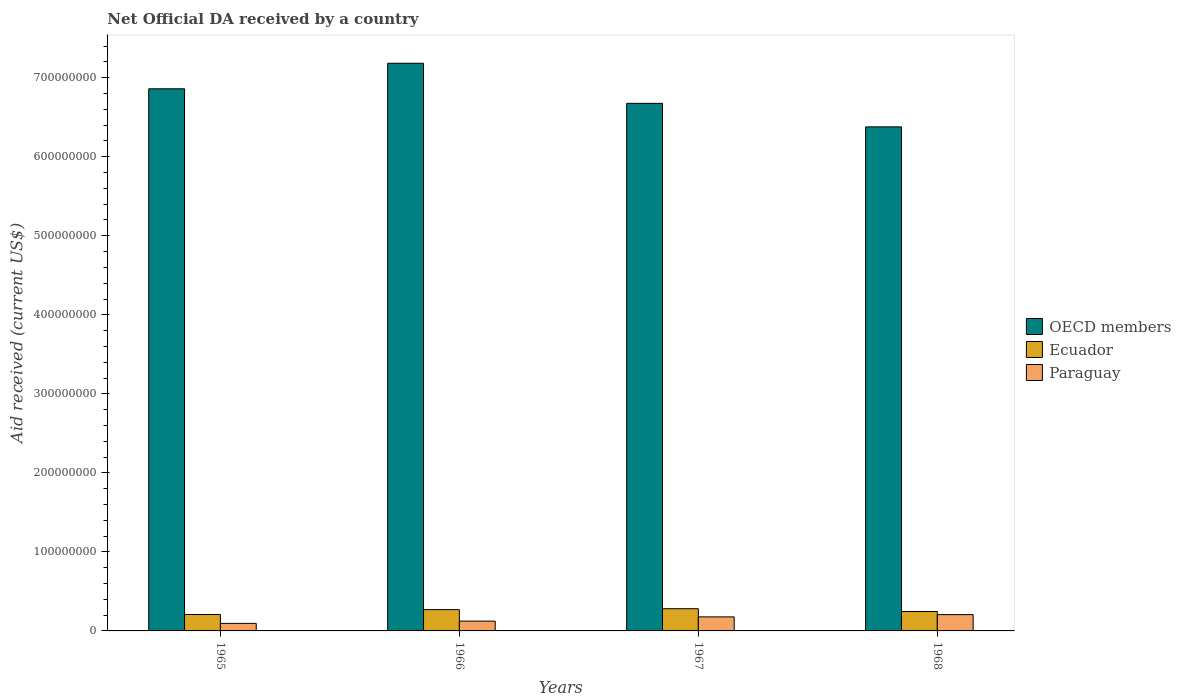How many different coloured bars are there?
Give a very brief answer. 3. Are the number of bars per tick equal to the number of legend labels?
Give a very brief answer. Yes. Are the number of bars on each tick of the X-axis equal?
Offer a terse response. Yes. What is the label of the 3rd group of bars from the left?
Your answer should be compact. 1967. What is the net official development assistance aid received in Ecuador in 1965?
Offer a very short reply. 2.08e+07. Across all years, what is the maximum net official development assistance aid received in OECD members?
Provide a short and direct response. 7.18e+08. Across all years, what is the minimum net official development assistance aid received in OECD members?
Offer a very short reply. 6.38e+08. In which year was the net official development assistance aid received in Ecuador maximum?
Provide a succinct answer. 1967. In which year was the net official development assistance aid received in Paraguay minimum?
Your answer should be compact. 1965. What is the total net official development assistance aid received in Ecuador in the graph?
Offer a terse response. 1.00e+08. What is the difference between the net official development assistance aid received in Paraguay in 1965 and that in 1966?
Your answer should be very brief. -2.85e+06. What is the difference between the net official development assistance aid received in OECD members in 1965 and the net official development assistance aid received in Paraguay in 1968?
Make the answer very short. 6.65e+08. What is the average net official development assistance aid received in OECD members per year?
Provide a short and direct response. 6.77e+08. In the year 1967, what is the difference between the net official development assistance aid received in OECD members and net official development assistance aid received in Paraguay?
Your answer should be very brief. 6.50e+08. In how many years, is the net official development assistance aid received in OECD members greater than 700000000 US$?
Provide a succinct answer. 1. What is the ratio of the net official development assistance aid received in Ecuador in 1967 to that in 1968?
Your response must be concise. 1.14. Is the net official development assistance aid received in Ecuador in 1965 less than that in 1967?
Your answer should be compact. Yes. Is the difference between the net official development assistance aid received in OECD members in 1967 and 1968 greater than the difference between the net official development assistance aid received in Paraguay in 1967 and 1968?
Offer a terse response. Yes. What is the difference between the highest and the second highest net official development assistance aid received in OECD members?
Give a very brief answer. 3.23e+07. What is the difference between the highest and the lowest net official development assistance aid received in Paraguay?
Your answer should be very brief. 1.11e+07. In how many years, is the net official development assistance aid received in Paraguay greater than the average net official development assistance aid received in Paraguay taken over all years?
Provide a short and direct response. 2. Is the sum of the net official development assistance aid received in Paraguay in 1965 and 1968 greater than the maximum net official development assistance aid received in Ecuador across all years?
Give a very brief answer. Yes. What does the 2nd bar from the left in 1968 represents?
Provide a short and direct response. Ecuador. What does the 2nd bar from the right in 1966 represents?
Offer a terse response. Ecuador. How many years are there in the graph?
Your answer should be compact. 4. Does the graph contain grids?
Ensure brevity in your answer.  No. How many legend labels are there?
Ensure brevity in your answer.  3. How are the legend labels stacked?
Make the answer very short. Vertical. What is the title of the graph?
Offer a very short reply. Net Official DA received by a country. Does "Jordan" appear as one of the legend labels in the graph?
Offer a very short reply. No. What is the label or title of the Y-axis?
Provide a succinct answer. Aid received (current US$). What is the Aid received (current US$) in OECD members in 1965?
Your answer should be very brief. 6.86e+08. What is the Aid received (current US$) in Ecuador in 1965?
Offer a very short reply. 2.08e+07. What is the Aid received (current US$) in Paraguay in 1965?
Provide a short and direct response. 9.55e+06. What is the Aid received (current US$) in OECD members in 1966?
Offer a very short reply. 7.18e+08. What is the Aid received (current US$) in Ecuador in 1966?
Offer a very short reply. 2.69e+07. What is the Aid received (current US$) in Paraguay in 1966?
Ensure brevity in your answer.  1.24e+07. What is the Aid received (current US$) in OECD members in 1967?
Your answer should be very brief. 6.68e+08. What is the Aid received (current US$) in Ecuador in 1967?
Offer a very short reply. 2.81e+07. What is the Aid received (current US$) in Paraguay in 1967?
Keep it short and to the point. 1.78e+07. What is the Aid received (current US$) in OECD members in 1968?
Your answer should be very brief. 6.38e+08. What is the Aid received (current US$) in Ecuador in 1968?
Offer a terse response. 2.46e+07. What is the Aid received (current US$) of Paraguay in 1968?
Your answer should be compact. 2.06e+07. Across all years, what is the maximum Aid received (current US$) in OECD members?
Your response must be concise. 7.18e+08. Across all years, what is the maximum Aid received (current US$) in Ecuador?
Your response must be concise. 2.81e+07. Across all years, what is the maximum Aid received (current US$) in Paraguay?
Give a very brief answer. 2.06e+07. Across all years, what is the minimum Aid received (current US$) of OECD members?
Your answer should be very brief. 6.38e+08. Across all years, what is the minimum Aid received (current US$) of Ecuador?
Keep it short and to the point. 2.08e+07. Across all years, what is the minimum Aid received (current US$) of Paraguay?
Keep it short and to the point. 9.55e+06. What is the total Aid received (current US$) of OECD members in the graph?
Your response must be concise. 2.71e+09. What is the total Aid received (current US$) in Ecuador in the graph?
Your answer should be very brief. 1.00e+08. What is the total Aid received (current US$) in Paraguay in the graph?
Your response must be concise. 6.04e+07. What is the difference between the Aid received (current US$) of OECD members in 1965 and that in 1966?
Offer a terse response. -3.23e+07. What is the difference between the Aid received (current US$) of Ecuador in 1965 and that in 1966?
Make the answer very short. -6.18e+06. What is the difference between the Aid received (current US$) of Paraguay in 1965 and that in 1966?
Give a very brief answer. -2.85e+06. What is the difference between the Aid received (current US$) of OECD members in 1965 and that in 1967?
Your response must be concise. 1.84e+07. What is the difference between the Aid received (current US$) in Ecuador in 1965 and that in 1967?
Your answer should be compact. -7.37e+06. What is the difference between the Aid received (current US$) in Paraguay in 1965 and that in 1967?
Keep it short and to the point. -8.21e+06. What is the difference between the Aid received (current US$) in OECD members in 1965 and that in 1968?
Keep it short and to the point. 4.82e+07. What is the difference between the Aid received (current US$) in Ecuador in 1965 and that in 1968?
Make the answer very short. -3.81e+06. What is the difference between the Aid received (current US$) in Paraguay in 1965 and that in 1968?
Provide a short and direct response. -1.11e+07. What is the difference between the Aid received (current US$) of OECD members in 1966 and that in 1967?
Ensure brevity in your answer.  5.07e+07. What is the difference between the Aid received (current US$) of Ecuador in 1966 and that in 1967?
Provide a succinct answer. -1.19e+06. What is the difference between the Aid received (current US$) of Paraguay in 1966 and that in 1967?
Ensure brevity in your answer.  -5.36e+06. What is the difference between the Aid received (current US$) of OECD members in 1966 and that in 1968?
Your answer should be very brief. 8.05e+07. What is the difference between the Aid received (current US$) in Ecuador in 1966 and that in 1968?
Your answer should be very brief. 2.37e+06. What is the difference between the Aid received (current US$) of Paraguay in 1966 and that in 1968?
Make the answer very short. -8.24e+06. What is the difference between the Aid received (current US$) of OECD members in 1967 and that in 1968?
Your answer should be compact. 2.98e+07. What is the difference between the Aid received (current US$) of Ecuador in 1967 and that in 1968?
Your answer should be very brief. 3.56e+06. What is the difference between the Aid received (current US$) of Paraguay in 1967 and that in 1968?
Make the answer very short. -2.88e+06. What is the difference between the Aid received (current US$) in OECD members in 1965 and the Aid received (current US$) in Ecuador in 1966?
Provide a short and direct response. 6.59e+08. What is the difference between the Aid received (current US$) in OECD members in 1965 and the Aid received (current US$) in Paraguay in 1966?
Make the answer very short. 6.74e+08. What is the difference between the Aid received (current US$) in Ecuador in 1965 and the Aid received (current US$) in Paraguay in 1966?
Give a very brief answer. 8.36e+06. What is the difference between the Aid received (current US$) in OECD members in 1965 and the Aid received (current US$) in Ecuador in 1967?
Give a very brief answer. 6.58e+08. What is the difference between the Aid received (current US$) in OECD members in 1965 and the Aid received (current US$) in Paraguay in 1967?
Offer a terse response. 6.68e+08. What is the difference between the Aid received (current US$) in Ecuador in 1965 and the Aid received (current US$) in Paraguay in 1967?
Offer a very short reply. 3.00e+06. What is the difference between the Aid received (current US$) in OECD members in 1965 and the Aid received (current US$) in Ecuador in 1968?
Offer a very short reply. 6.61e+08. What is the difference between the Aid received (current US$) in OECD members in 1965 and the Aid received (current US$) in Paraguay in 1968?
Provide a succinct answer. 6.65e+08. What is the difference between the Aid received (current US$) in OECD members in 1966 and the Aid received (current US$) in Ecuador in 1967?
Keep it short and to the point. 6.90e+08. What is the difference between the Aid received (current US$) of OECD members in 1966 and the Aid received (current US$) of Paraguay in 1967?
Your answer should be compact. 7.01e+08. What is the difference between the Aid received (current US$) in Ecuador in 1966 and the Aid received (current US$) in Paraguay in 1967?
Offer a terse response. 9.18e+06. What is the difference between the Aid received (current US$) in OECD members in 1966 and the Aid received (current US$) in Ecuador in 1968?
Offer a very short reply. 6.94e+08. What is the difference between the Aid received (current US$) of OECD members in 1966 and the Aid received (current US$) of Paraguay in 1968?
Provide a short and direct response. 6.98e+08. What is the difference between the Aid received (current US$) of Ecuador in 1966 and the Aid received (current US$) of Paraguay in 1968?
Provide a short and direct response. 6.30e+06. What is the difference between the Aid received (current US$) of OECD members in 1967 and the Aid received (current US$) of Ecuador in 1968?
Your answer should be compact. 6.43e+08. What is the difference between the Aid received (current US$) in OECD members in 1967 and the Aid received (current US$) in Paraguay in 1968?
Your answer should be very brief. 6.47e+08. What is the difference between the Aid received (current US$) of Ecuador in 1967 and the Aid received (current US$) of Paraguay in 1968?
Provide a short and direct response. 7.49e+06. What is the average Aid received (current US$) in OECD members per year?
Give a very brief answer. 6.77e+08. What is the average Aid received (current US$) in Ecuador per year?
Give a very brief answer. 2.51e+07. What is the average Aid received (current US$) of Paraguay per year?
Give a very brief answer. 1.51e+07. In the year 1965, what is the difference between the Aid received (current US$) of OECD members and Aid received (current US$) of Ecuador?
Ensure brevity in your answer.  6.65e+08. In the year 1965, what is the difference between the Aid received (current US$) of OECD members and Aid received (current US$) of Paraguay?
Your response must be concise. 6.76e+08. In the year 1965, what is the difference between the Aid received (current US$) of Ecuador and Aid received (current US$) of Paraguay?
Ensure brevity in your answer.  1.12e+07. In the year 1966, what is the difference between the Aid received (current US$) in OECD members and Aid received (current US$) in Ecuador?
Offer a terse response. 6.91e+08. In the year 1966, what is the difference between the Aid received (current US$) of OECD members and Aid received (current US$) of Paraguay?
Your answer should be compact. 7.06e+08. In the year 1966, what is the difference between the Aid received (current US$) in Ecuador and Aid received (current US$) in Paraguay?
Your answer should be compact. 1.45e+07. In the year 1967, what is the difference between the Aid received (current US$) in OECD members and Aid received (current US$) in Ecuador?
Offer a terse response. 6.39e+08. In the year 1967, what is the difference between the Aid received (current US$) of OECD members and Aid received (current US$) of Paraguay?
Offer a terse response. 6.50e+08. In the year 1967, what is the difference between the Aid received (current US$) of Ecuador and Aid received (current US$) of Paraguay?
Give a very brief answer. 1.04e+07. In the year 1968, what is the difference between the Aid received (current US$) of OECD members and Aid received (current US$) of Ecuador?
Offer a terse response. 6.13e+08. In the year 1968, what is the difference between the Aid received (current US$) in OECD members and Aid received (current US$) in Paraguay?
Your answer should be compact. 6.17e+08. In the year 1968, what is the difference between the Aid received (current US$) in Ecuador and Aid received (current US$) in Paraguay?
Your answer should be compact. 3.93e+06. What is the ratio of the Aid received (current US$) in OECD members in 1965 to that in 1966?
Your answer should be very brief. 0.95. What is the ratio of the Aid received (current US$) in Ecuador in 1965 to that in 1966?
Provide a succinct answer. 0.77. What is the ratio of the Aid received (current US$) in Paraguay in 1965 to that in 1966?
Keep it short and to the point. 0.77. What is the ratio of the Aid received (current US$) of OECD members in 1965 to that in 1967?
Ensure brevity in your answer.  1.03. What is the ratio of the Aid received (current US$) in Ecuador in 1965 to that in 1967?
Your answer should be compact. 0.74. What is the ratio of the Aid received (current US$) in Paraguay in 1965 to that in 1967?
Offer a terse response. 0.54. What is the ratio of the Aid received (current US$) in OECD members in 1965 to that in 1968?
Offer a very short reply. 1.08. What is the ratio of the Aid received (current US$) of Ecuador in 1965 to that in 1968?
Your response must be concise. 0.84. What is the ratio of the Aid received (current US$) in Paraguay in 1965 to that in 1968?
Give a very brief answer. 0.46. What is the ratio of the Aid received (current US$) in OECD members in 1966 to that in 1967?
Give a very brief answer. 1.08. What is the ratio of the Aid received (current US$) of Ecuador in 1966 to that in 1967?
Provide a succinct answer. 0.96. What is the ratio of the Aid received (current US$) in Paraguay in 1966 to that in 1967?
Make the answer very short. 0.7. What is the ratio of the Aid received (current US$) in OECD members in 1966 to that in 1968?
Your answer should be compact. 1.13. What is the ratio of the Aid received (current US$) of Ecuador in 1966 to that in 1968?
Offer a very short reply. 1.1. What is the ratio of the Aid received (current US$) of Paraguay in 1966 to that in 1968?
Make the answer very short. 0.6. What is the ratio of the Aid received (current US$) in OECD members in 1967 to that in 1968?
Offer a terse response. 1.05. What is the ratio of the Aid received (current US$) of Ecuador in 1967 to that in 1968?
Provide a succinct answer. 1.14. What is the ratio of the Aid received (current US$) in Paraguay in 1967 to that in 1968?
Offer a terse response. 0.86. What is the difference between the highest and the second highest Aid received (current US$) of OECD members?
Provide a succinct answer. 3.23e+07. What is the difference between the highest and the second highest Aid received (current US$) in Ecuador?
Your response must be concise. 1.19e+06. What is the difference between the highest and the second highest Aid received (current US$) of Paraguay?
Give a very brief answer. 2.88e+06. What is the difference between the highest and the lowest Aid received (current US$) in OECD members?
Provide a succinct answer. 8.05e+07. What is the difference between the highest and the lowest Aid received (current US$) of Ecuador?
Give a very brief answer. 7.37e+06. What is the difference between the highest and the lowest Aid received (current US$) in Paraguay?
Ensure brevity in your answer.  1.11e+07. 